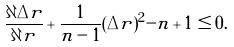Convert formula to latex. <formula><loc_0><loc_0><loc_500><loc_500>\frac { \partial \Delta r } { \partial r } + \frac { 1 } { n - 1 } ( \Delta r ) ^ { 2 } - n + 1 \leq 0 .</formula> 